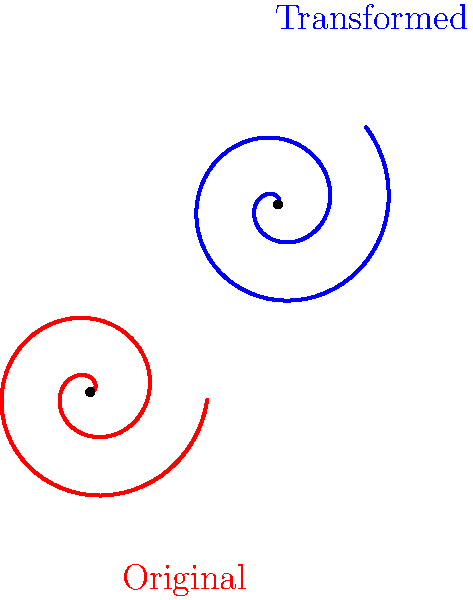In the spirit of Zen philosophy and the cycle of life, consider the transformation of a spiral shape. The original red spiral is defined by the parametric equations $x = at\cos(t)$ and $y = at\sin(t)$, where $a$ is a constant and $t$ is the parameter. The blue spiral is obtained by rotating the original spiral by 45° clockwise around the origin and then translating it by the vector $(2,2)$. What are the parametric equations of the transformed blue spiral? Let's approach this transformation step-by-step, reflecting on the cyclical nature of change:

1) The original spiral is given by:
   $x = at\cos(t)$
   $y = at\sin(t)$

2) First, we apply a rotation of 45° clockwise. The rotation matrix for a clockwise rotation by θ is:
   $$\begin{pmatrix} \cos\theta & \sin\theta \\ -\sin\theta & \cos\theta \end{pmatrix}$$

   For 45°, $\cos(45°) = \sin(45°) = \frac{1}{\sqrt{2}}$

3) Applying this rotation:
   $x' = \frac{1}{\sqrt{2}}(at\cos(t)) + \frac{1}{\sqrt{2}}(at\sin(t))$
   $y' = -\frac{1}{\sqrt{2}}(at\cos(t)) + \frac{1}{\sqrt{2}}(at\sin(t))$

4) Now, we apply the translation $(2,2)$:
   $x'' = x' + 2 = \frac{1}{\sqrt{2}}(at\cos(t)) + \frac{1}{\sqrt{2}}(at\sin(t)) + 2$
   $y'' = y' + 2 = -\frac{1}{\sqrt{2}}(at\cos(t)) + \frac{1}{\sqrt{2}}(at\sin(t)) + 2$

5) Simplifying:
   $x'' = \frac{at}{\sqrt{2}}(\cos(t) + \sin(t)) + 2$
   $y'' = \frac{at}{\sqrt{2}}(-\cos(t) + \sin(t)) + 2$

These are the parametric equations of the transformed spiral.
Answer: $x = \frac{at}{\sqrt{2}}(\cos(t) + \sin(t)) + 2$, $y = \frac{at}{\sqrt{2}}(-\cos(t) + \sin(t)) + 2$ 